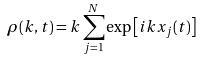Convert formula to latex. <formula><loc_0><loc_0><loc_500><loc_500>\rho ( k , t ) = k \sum _ { j = 1 } ^ { N } \exp \left [ i k x _ { j } ( t ) \right ]</formula> 